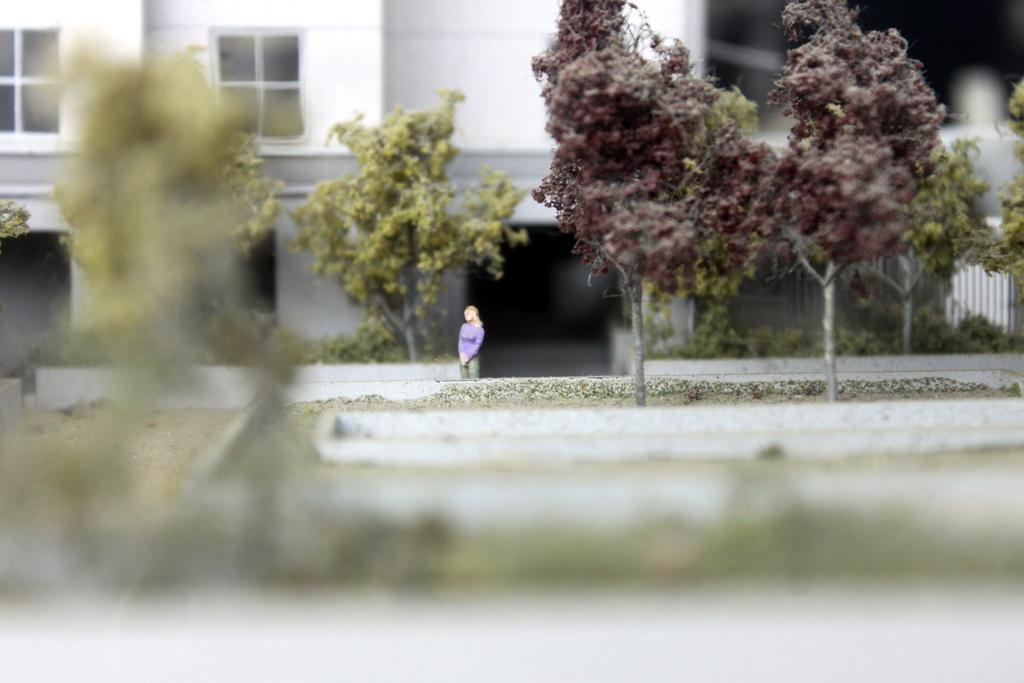Who is the main subject in the image? There is a woman in the image. What is the woman wearing? The woman is wearing a purple t-shirt. What is the woman doing in the image? The woman is standing. What can be seen in the background of the image? There is a white building with glass windows in the background. What is the blurred image in the front bottom side of the image? Unfortunately, the details of the blurred image cannot be determined from the provided facts. What type of chairs does the woman's uncle sit on in the image? There is no mention of chairs, an uncle, or any sitting in the image. The woman is standing, and the focus is on her and the background. 